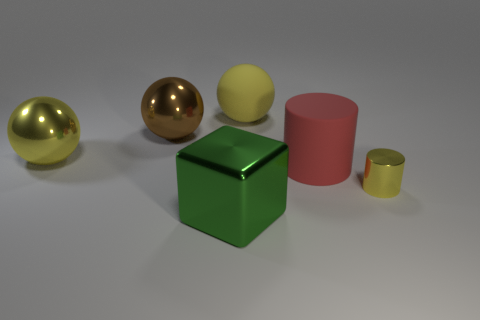There is a brown metal ball; is it the same size as the yellow thing that is in front of the large red matte thing?
Provide a short and direct response. No. Is there a shiny cube behind the large sphere that is right of the brown thing?
Ensure brevity in your answer.  No. Is there a cyan rubber object of the same shape as the large green metallic thing?
Provide a short and direct response. No. There is a thing that is in front of the yellow metal object in front of the big red thing; what number of red rubber things are to the left of it?
Make the answer very short. 0. There is a large cube; is it the same color as the big rubber object in front of the big yellow rubber sphere?
Your answer should be very brief. No. How many objects are either big balls to the right of the large yellow metal thing or yellow metallic things left of the big cube?
Offer a terse response. 3. Are there more yellow spheres right of the large rubber sphere than green metal objects that are to the left of the brown thing?
Provide a succinct answer. No. There is a yellow object that is left of the large thing in front of the yellow metal thing that is in front of the large red object; what is its material?
Give a very brief answer. Metal. Is the shape of the large rubber thing in front of the yellow matte sphere the same as the yellow metal thing on the right side of the green object?
Make the answer very short. Yes. Is there a green matte sphere of the same size as the green thing?
Ensure brevity in your answer.  No. 